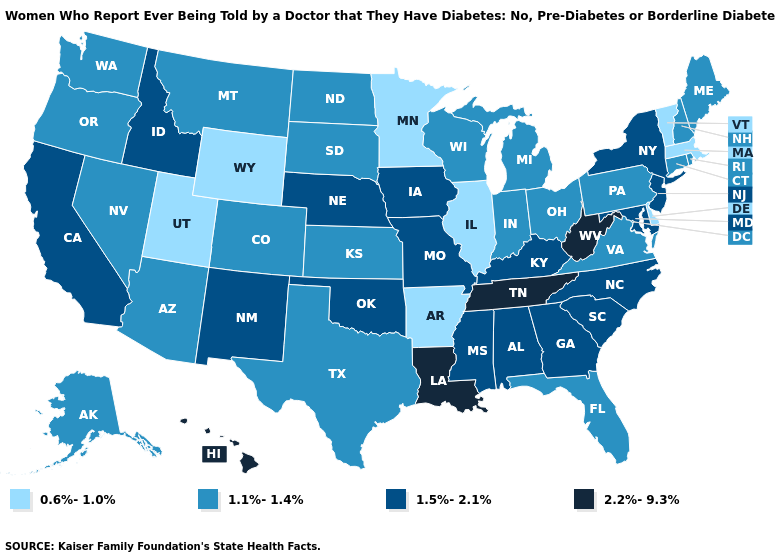What is the value of Utah?
Concise answer only. 0.6%-1.0%. What is the value of Texas?
Concise answer only. 1.1%-1.4%. What is the value of Hawaii?
Quick response, please. 2.2%-9.3%. Which states have the lowest value in the South?
Be succinct. Arkansas, Delaware. Which states have the lowest value in the South?
Give a very brief answer. Arkansas, Delaware. Among the states that border Washington , which have the highest value?
Write a very short answer. Idaho. What is the lowest value in states that border Connecticut?
Keep it brief. 0.6%-1.0%. What is the highest value in the MidWest ?
Concise answer only. 1.5%-2.1%. What is the lowest value in states that border South Carolina?
Keep it brief. 1.5%-2.1%. Does Mississippi have the highest value in the South?
Keep it brief. No. Does Massachusetts have the lowest value in the Northeast?
Short answer required. Yes. What is the value of Pennsylvania?
Quick response, please. 1.1%-1.4%. What is the value of South Dakota?
Write a very short answer. 1.1%-1.4%. Name the states that have a value in the range 0.6%-1.0%?
Keep it brief. Arkansas, Delaware, Illinois, Massachusetts, Minnesota, Utah, Vermont, Wyoming. What is the lowest value in the MidWest?
Be succinct. 0.6%-1.0%. 